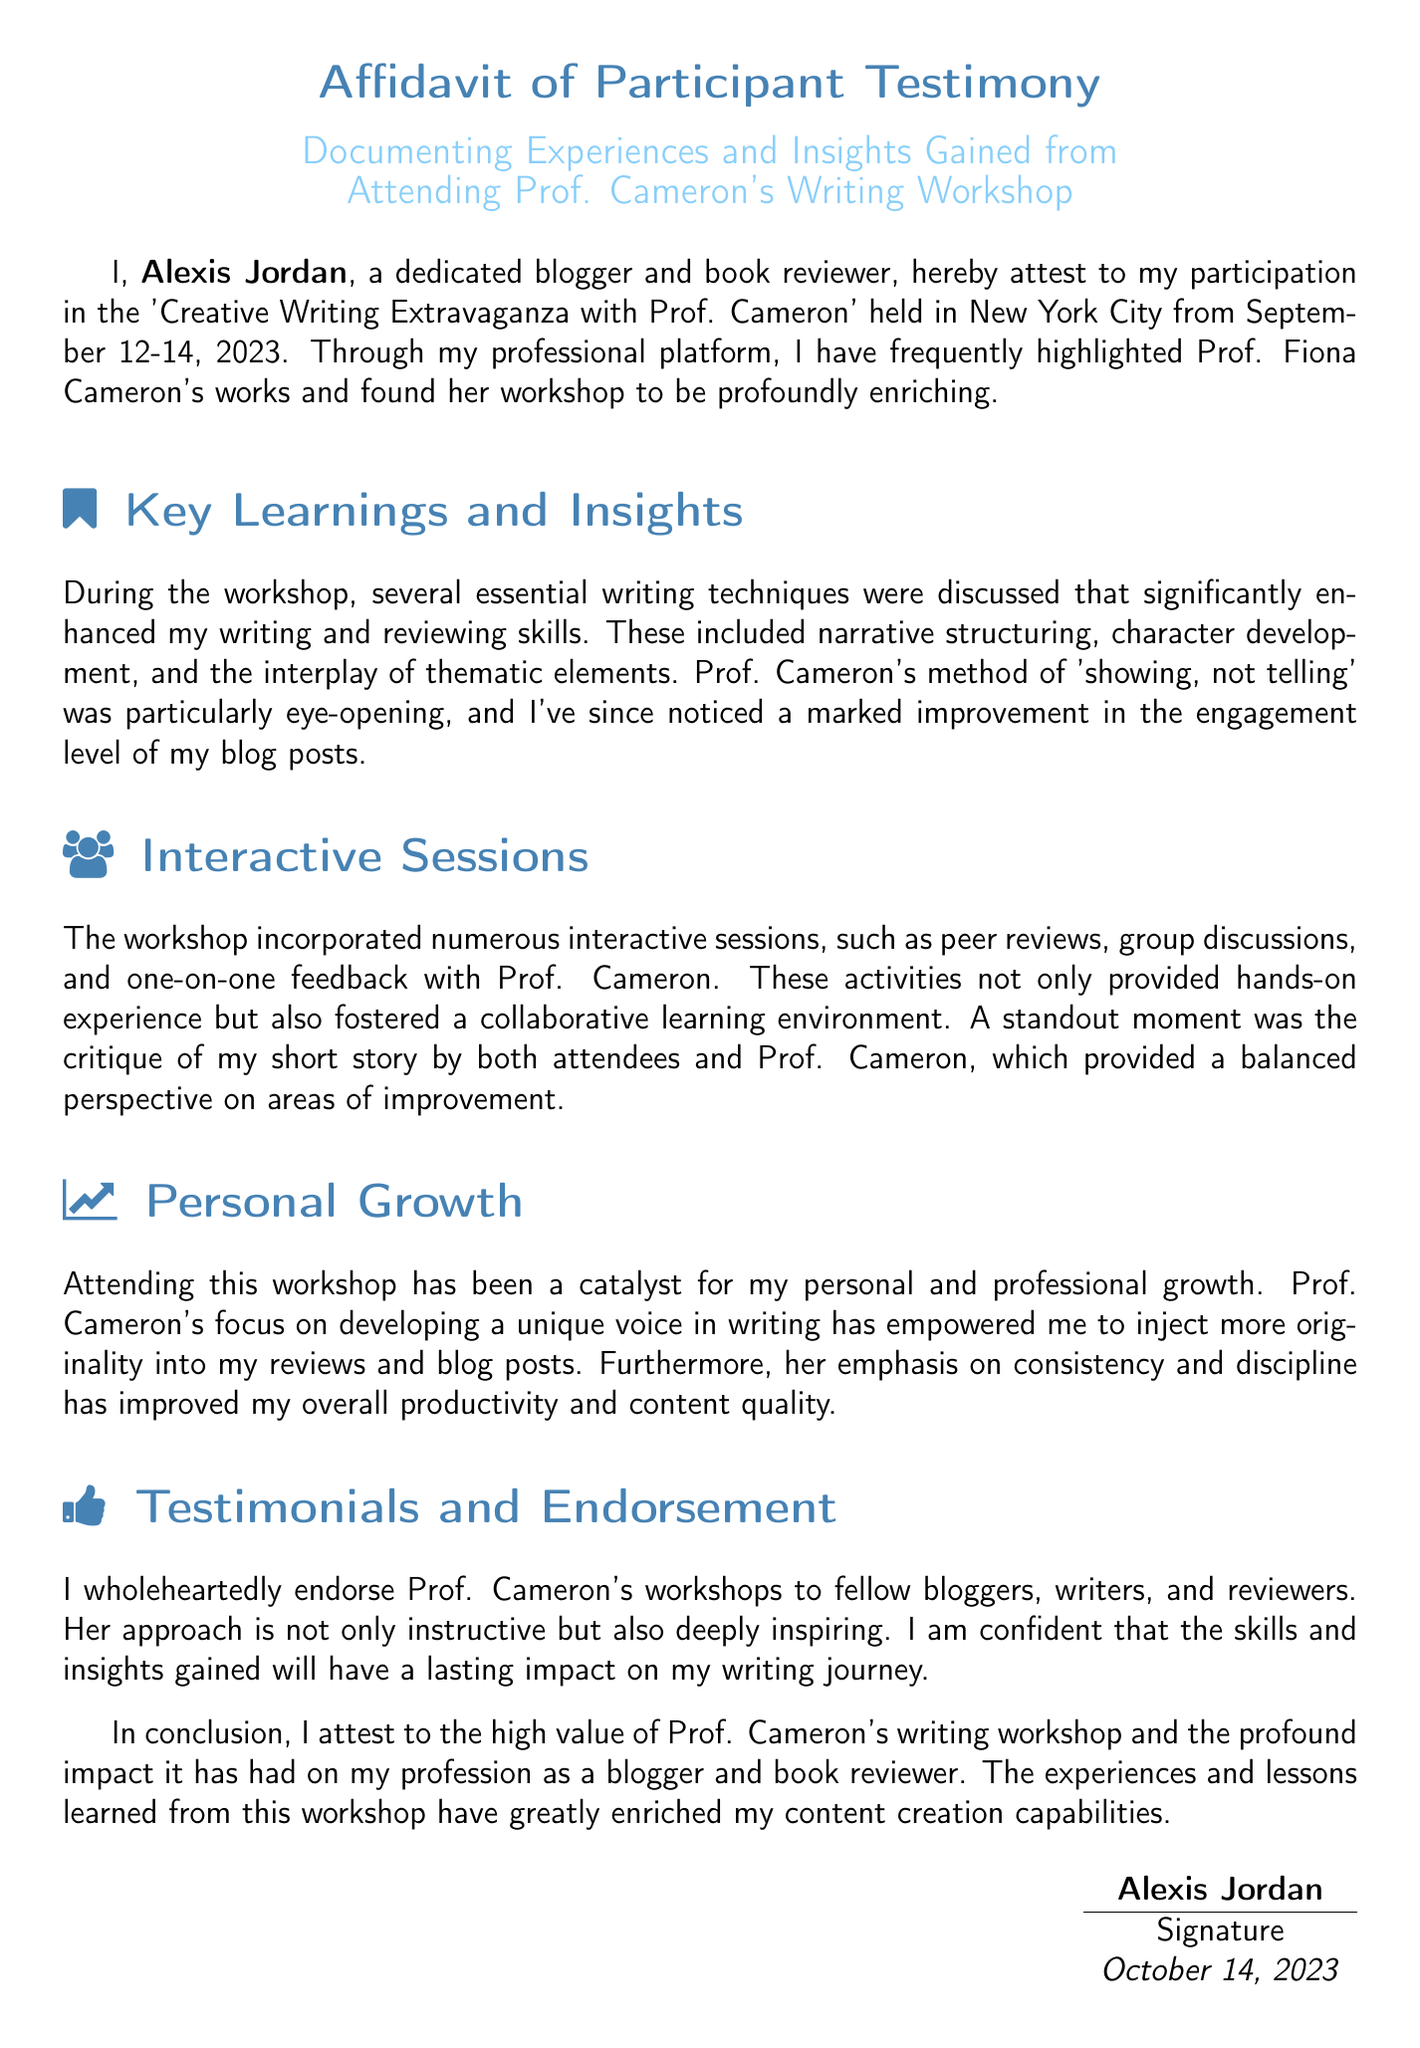What is the name of the participant? The name of the participant is stated in the document, which is Alexis Jordan.
Answer: Alexis Jordan When was the workshop held? The document specifies the dates of the workshop, from September 12 to September 14, 2023.
Answer: September 12-14, 2023 What city hosted the workshop? The document mentions the location of the workshop, which is New York City.
Answer: New York City What key writing technique was highlighted in the workshop? The document discusses essential writing techniques, one of which was 'showing, not telling'.
Answer: showing, not telling Which feature of the workshop involved direct feedback? The interactive sessions mentioned in the document incorporated peer reviews and one-on-one feedback.
Answer: one-on-one feedback What kind of environment did the interactive sessions foster? The document describes the collaborative atmosphere created during the interactive activities of the workshop.
Answer: collaborative learning environment What aspect of writing did Prof. Cameron emphasize for personal growth? The document states that Prof. Cameron focused on developing a unique voice in writing for personal growth.
Answer: unique voice How does the participant view the impact of the workshop on their blogging? The document concludes with the participant affirming the high value of the workshop's impact on their profession.
Answer: high value What date was the affidavit signed? The document indicates the date when the affidavit was signed is October 14, 2023.
Answer: October 14, 2023 